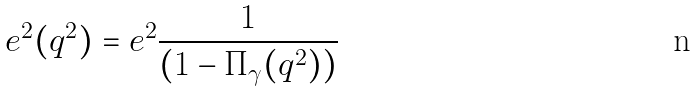Convert formula to latex. <formula><loc_0><loc_0><loc_500><loc_500>e ^ { 2 } ( q ^ { 2 } ) = e ^ { 2 } \frac { 1 } { ( 1 - \Pi _ { \gamma } ( q ^ { 2 } ) ) }</formula> 